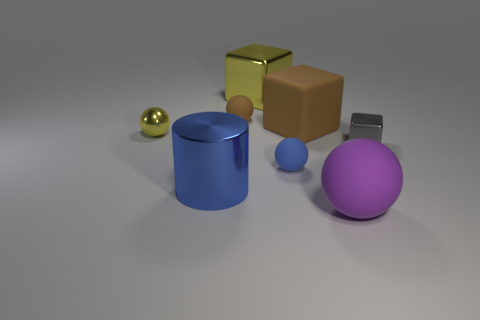Subtract all matte balls. How many balls are left? 1 Add 2 large cyan rubber objects. How many objects exist? 10 Subtract all brown balls. How many balls are left? 3 Add 4 small blue matte spheres. How many small blue matte spheres exist? 5 Subtract 0 green cylinders. How many objects are left? 8 Subtract all cylinders. How many objects are left? 7 Subtract 1 cylinders. How many cylinders are left? 0 Subtract all green balls. Subtract all purple cubes. How many balls are left? 4 Subtract all cyan balls. How many yellow cubes are left? 1 Subtract all gray things. Subtract all balls. How many objects are left? 3 